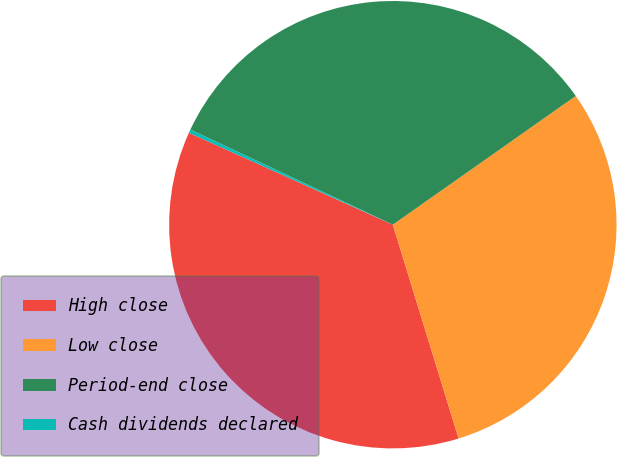<chart> <loc_0><loc_0><loc_500><loc_500><pie_chart><fcel>High close<fcel>Low close<fcel>Period-end close<fcel>Cash dividends declared<nl><fcel>36.49%<fcel>30.01%<fcel>33.25%<fcel>0.25%<nl></chart> 